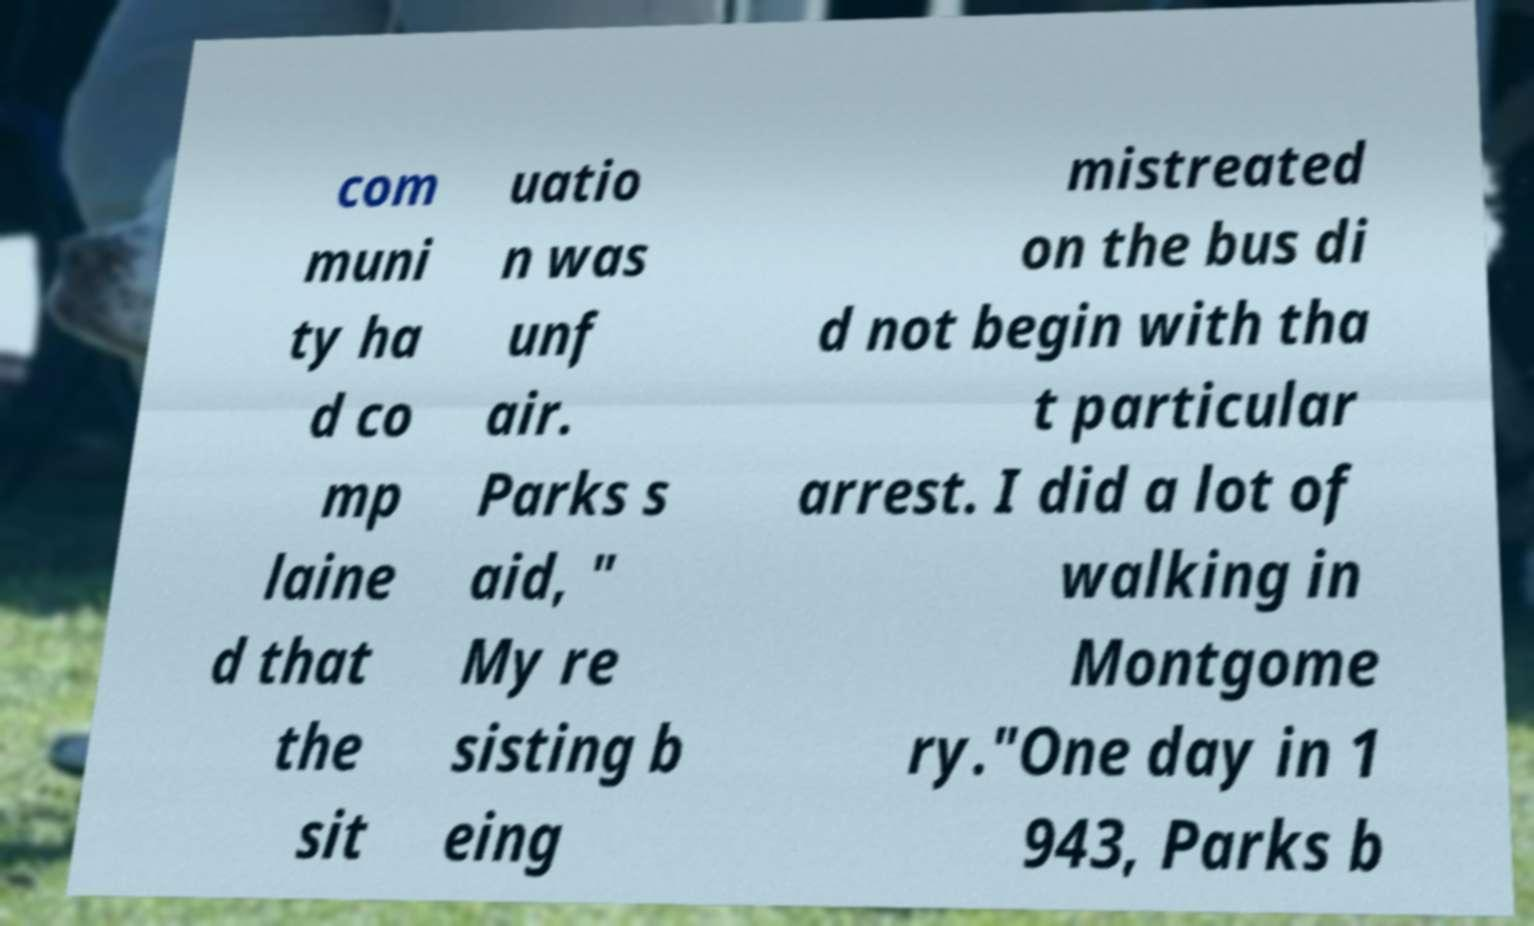Please read and relay the text visible in this image. What does it say? com muni ty ha d co mp laine d that the sit uatio n was unf air. Parks s aid, " My re sisting b eing mistreated on the bus di d not begin with tha t particular arrest. I did a lot of walking in Montgome ry."One day in 1 943, Parks b 